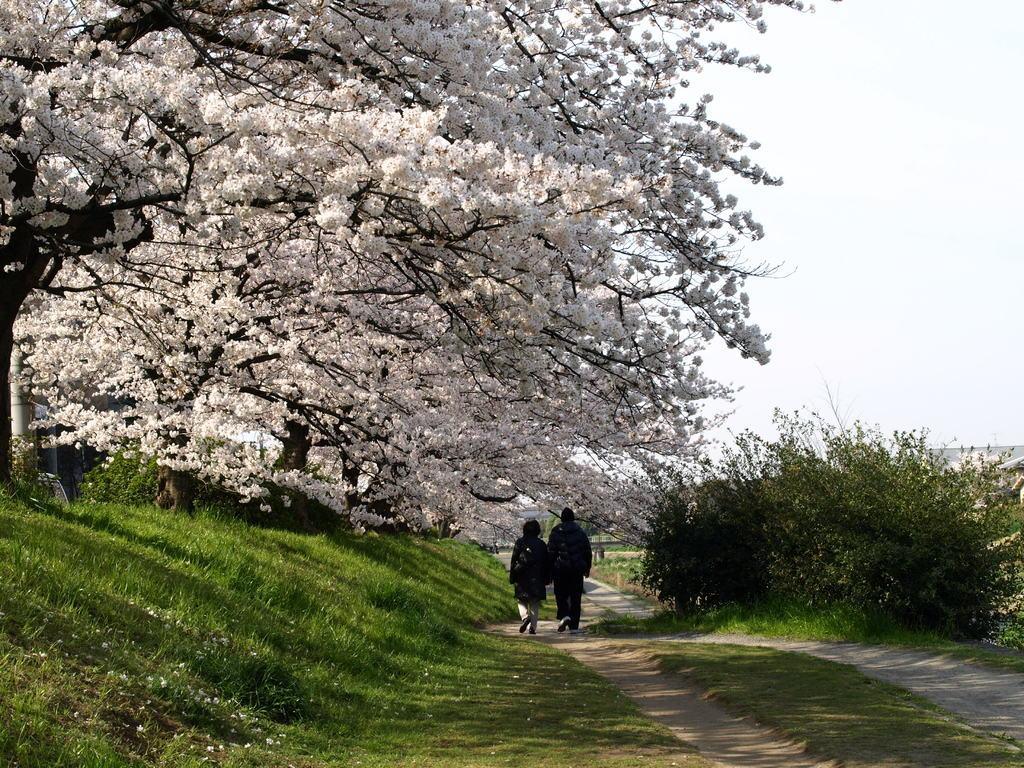Please provide a concise description of this image. In this picture I can see two persons are standing on the ground. I can also see grass, path and trees. In the background I can see sky. 